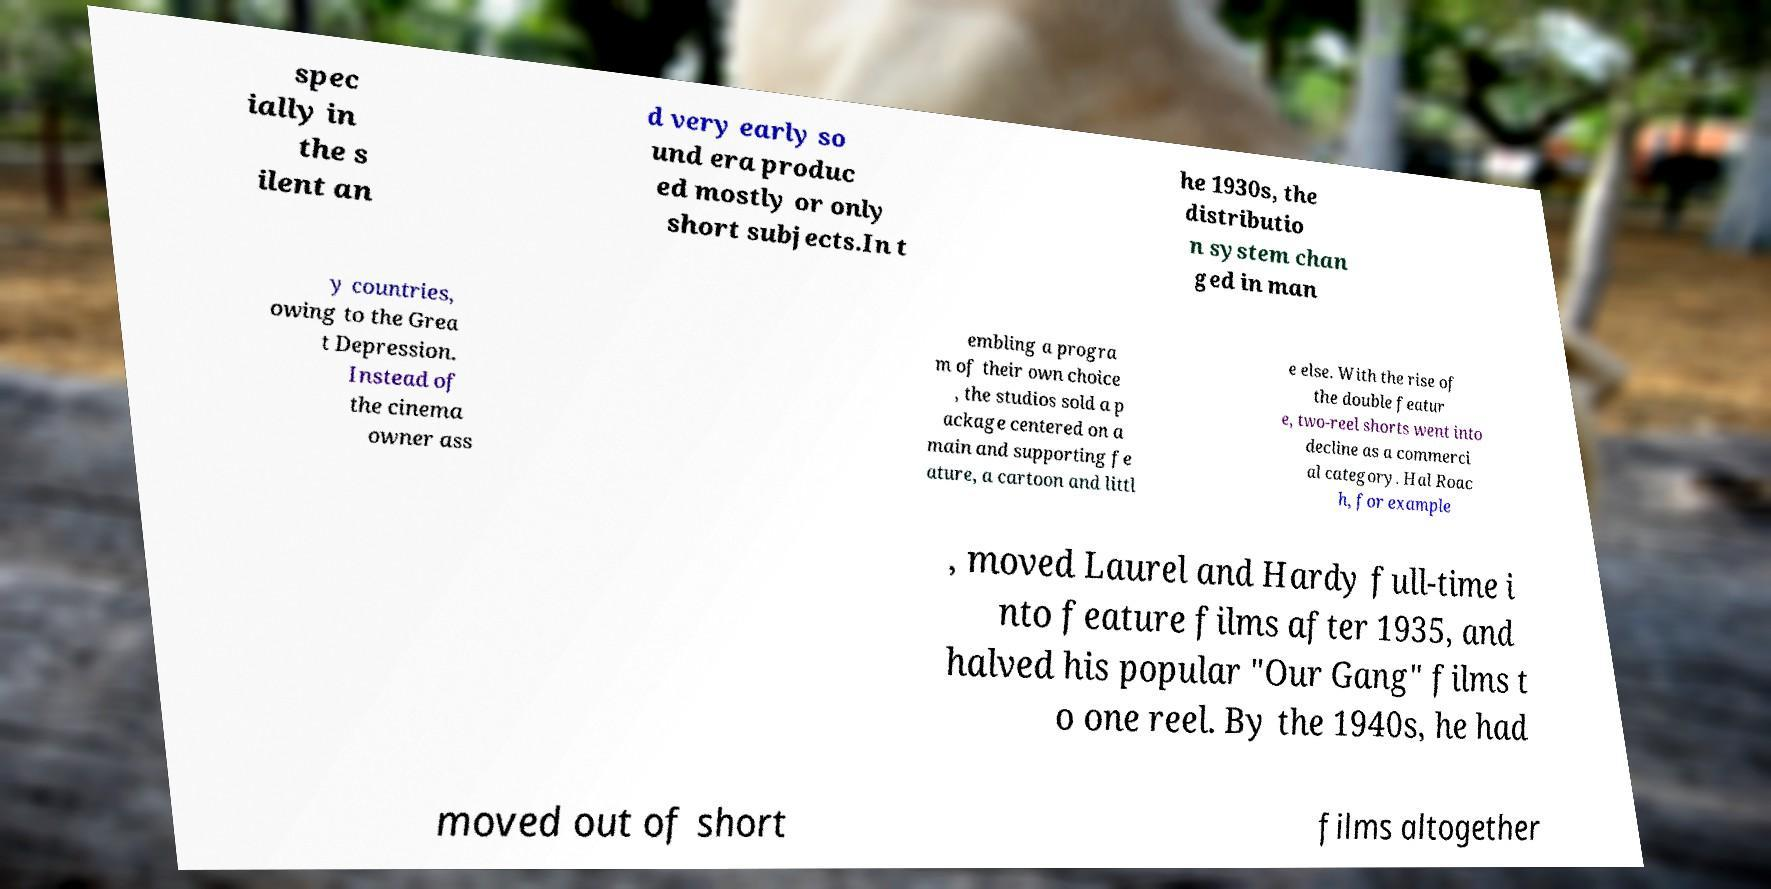Can you accurately transcribe the text from the provided image for me? spec ially in the s ilent an d very early so und era produc ed mostly or only short subjects.In t he 1930s, the distributio n system chan ged in man y countries, owing to the Grea t Depression. Instead of the cinema owner ass embling a progra m of their own choice , the studios sold a p ackage centered on a main and supporting fe ature, a cartoon and littl e else. With the rise of the double featur e, two-reel shorts went into decline as a commerci al category. Hal Roac h, for example , moved Laurel and Hardy full-time i nto feature films after 1935, and halved his popular "Our Gang" films t o one reel. By the 1940s, he had moved out of short films altogether 